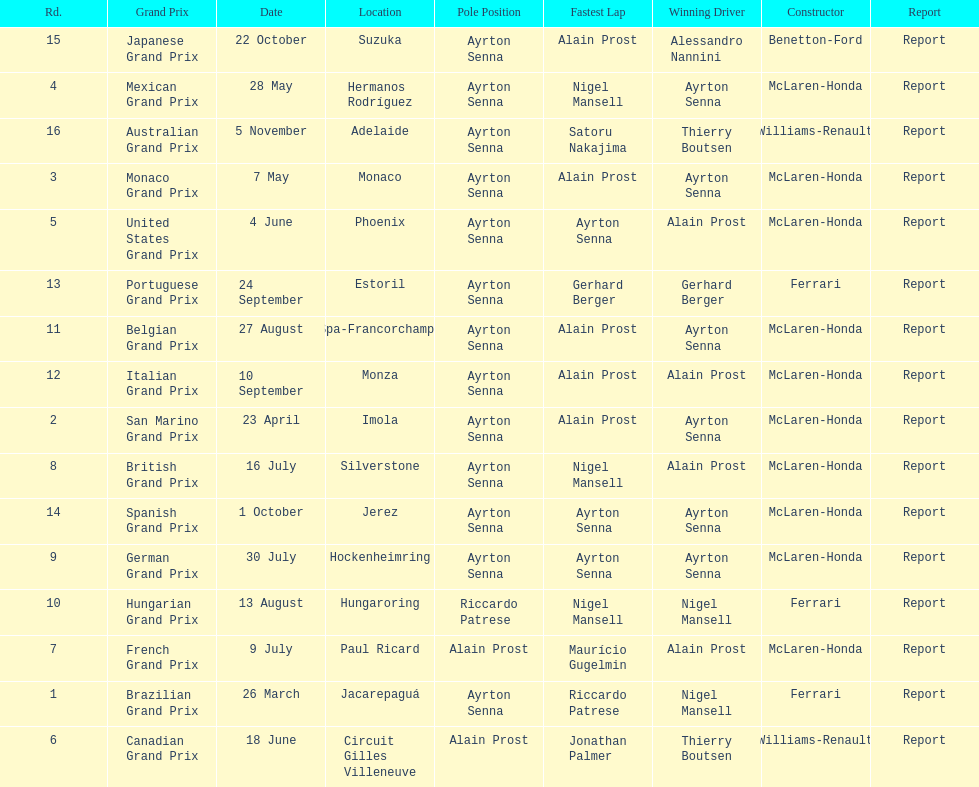How many races occurred before alain prost won a pole position? 5. 